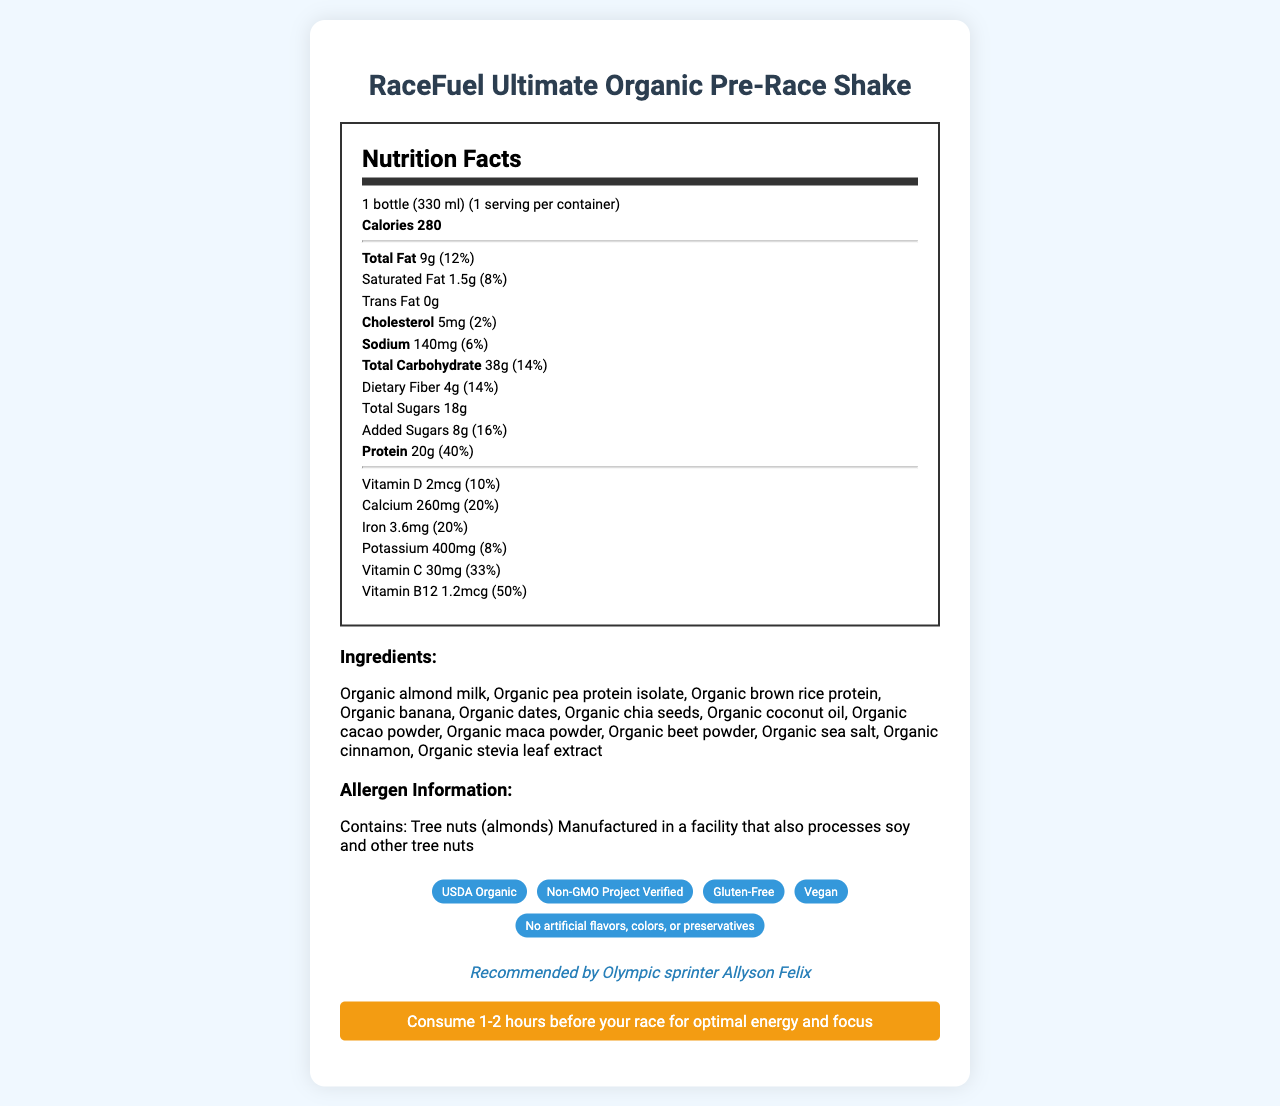What is the serving size of the RaceFuel Ultimate Organic Pre-Race Shake? The document specifies that the serving size is "1 bottle (330 ml)".
Answer: 1 bottle (330 ml) How many calories are there per bottle? The document lists the calories per bottle as 280.
Answer: 280 What is the total carbohydrate amount in one serving? The document mentions that the total carbohydrate amount is 38g.
Answer: 38g Who endorses the RaceFuel Ultimate Organic Pre-Race Shake? The endorsement is explicitly mentioned in the document as Olympic sprinter Allyson Felix.
Answer: Olympic sprinter Allyson Felix What should you avoid if you are allergic to tree nuts? The document states that the shake contains almonds, which are tree nuts.
Answer: RaceFuel Ultimate Organic Pre-Race Shake What percentage of the daily value of protein does one serving provide? The document indicates that one serving provides 40% of the daily value of protein.
Answer: 40% Which athlete recommends this product? The document states that Allyson Felix recommends the product.
Answer: Allyson Felix Multiple Choice: How much dietary fiber does the shake contain?
A. 2g
B. 4g
C. 6g
D. 8g The document states that there are 4g of dietary fiber in one serving.
Answer: B Multiple Choice: Which of the following is NOT listed as an ingredient in the shake?
I. Organic almond milk
II. Organic coconut oil
III. Cane sugar
IV. Organic maca powder The document lists all ingredients, and cane sugar is not among them.
Answer: III Is the RaceFuel Ultimate Organic Pre-Race Shake gluten-free? The document includes a claim that the product is gluten-free.
Answer: Yes Summarize the main features of the RaceFuel Ultimate Organic Pre-Race Shake. The summary captures the main nutritional information, endorsements, and purpose of the product.
Answer: The RaceFuel Ultimate Organic Pre-Race Shake is an organic, non-GMO, gluten-free, and vegan meal replacement shake endorsed by Olympic sprinter Allyson Felix. It contains balanced macronutrients including 9g of total fat, 38g of carbohydrates, and 20g of protein per serving. It also provides significant daily values of vitamins and minerals and should be consumed 1-2 hours before a race. What is the source of the added sugars? The document does not specify the source of the added sugars; it only mentions the amount and daily value.
Answer: Not enough information How many servings are there per container? The document states that there is 1 serving per container.
Answer: 1 